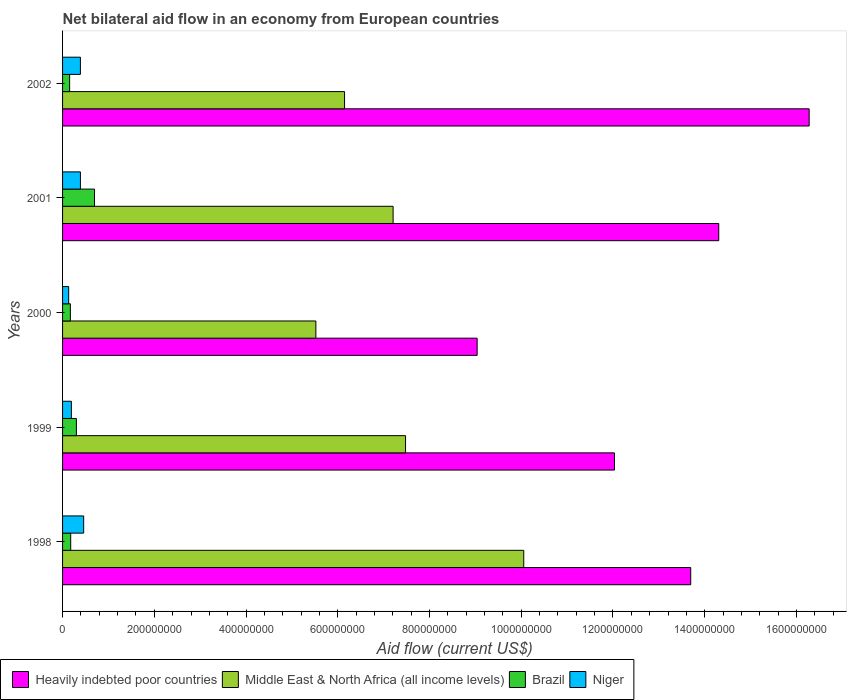How many groups of bars are there?
Your answer should be very brief. 5. Are the number of bars per tick equal to the number of legend labels?
Offer a terse response. Yes. How many bars are there on the 1st tick from the bottom?
Your response must be concise. 4. What is the label of the 2nd group of bars from the top?
Keep it short and to the point. 2001. In how many cases, is the number of bars for a given year not equal to the number of legend labels?
Offer a terse response. 0. What is the net bilateral aid flow in Heavily indebted poor countries in 2001?
Provide a succinct answer. 1.43e+09. Across all years, what is the maximum net bilateral aid flow in Middle East & North Africa (all income levels)?
Offer a very short reply. 1.01e+09. Across all years, what is the minimum net bilateral aid flow in Niger?
Your answer should be compact. 1.33e+07. In which year was the net bilateral aid flow in Brazil maximum?
Keep it short and to the point. 2001. In which year was the net bilateral aid flow in Heavily indebted poor countries minimum?
Keep it short and to the point. 2000. What is the total net bilateral aid flow in Brazil in the graph?
Give a very brief answer. 1.50e+08. What is the difference between the net bilateral aid flow in Brazil in 1999 and that in 2002?
Your answer should be very brief. 1.48e+07. What is the difference between the net bilateral aid flow in Niger in 2000 and the net bilateral aid flow in Heavily indebted poor countries in 1998?
Offer a terse response. -1.36e+09. What is the average net bilateral aid flow in Middle East & North Africa (all income levels) per year?
Keep it short and to the point. 7.28e+08. In the year 2000, what is the difference between the net bilateral aid flow in Brazil and net bilateral aid flow in Middle East & North Africa (all income levels)?
Offer a very short reply. -5.35e+08. What is the ratio of the net bilateral aid flow in Niger in 1998 to that in 2001?
Offer a very short reply. 1.18. What is the difference between the highest and the second highest net bilateral aid flow in Niger?
Keep it short and to the point. 7.09e+06. What is the difference between the highest and the lowest net bilateral aid flow in Heavily indebted poor countries?
Provide a short and direct response. 7.24e+08. In how many years, is the net bilateral aid flow in Heavily indebted poor countries greater than the average net bilateral aid flow in Heavily indebted poor countries taken over all years?
Provide a short and direct response. 3. Is the sum of the net bilateral aid flow in Middle East & North Africa (all income levels) in 2000 and 2001 greater than the maximum net bilateral aid flow in Niger across all years?
Your answer should be compact. Yes. Is it the case that in every year, the sum of the net bilateral aid flow in Heavily indebted poor countries and net bilateral aid flow in Niger is greater than the sum of net bilateral aid flow in Brazil and net bilateral aid flow in Middle East & North Africa (all income levels)?
Keep it short and to the point. No. What does the 4th bar from the top in 2001 represents?
Your answer should be compact. Heavily indebted poor countries. What does the 4th bar from the bottom in 1999 represents?
Ensure brevity in your answer.  Niger. How many years are there in the graph?
Ensure brevity in your answer.  5. Does the graph contain any zero values?
Your answer should be very brief. No. Where does the legend appear in the graph?
Offer a terse response. Bottom left. How many legend labels are there?
Ensure brevity in your answer.  4. How are the legend labels stacked?
Provide a succinct answer. Horizontal. What is the title of the graph?
Keep it short and to the point. Net bilateral aid flow in an economy from European countries. Does "Guinea-Bissau" appear as one of the legend labels in the graph?
Offer a terse response. No. What is the label or title of the X-axis?
Provide a short and direct response. Aid flow (current US$). What is the label or title of the Y-axis?
Your answer should be compact. Years. What is the Aid flow (current US$) of Heavily indebted poor countries in 1998?
Make the answer very short. 1.37e+09. What is the Aid flow (current US$) in Middle East & North Africa (all income levels) in 1998?
Offer a terse response. 1.01e+09. What is the Aid flow (current US$) of Brazil in 1998?
Make the answer very short. 1.77e+07. What is the Aid flow (current US$) in Niger in 1998?
Provide a succinct answer. 4.60e+07. What is the Aid flow (current US$) in Heavily indebted poor countries in 1999?
Your response must be concise. 1.20e+09. What is the Aid flow (current US$) in Middle East & North Africa (all income levels) in 1999?
Make the answer very short. 7.48e+08. What is the Aid flow (current US$) of Brazil in 1999?
Your answer should be very brief. 3.02e+07. What is the Aid flow (current US$) in Niger in 1999?
Provide a succinct answer. 1.92e+07. What is the Aid flow (current US$) in Heavily indebted poor countries in 2000?
Offer a terse response. 9.04e+08. What is the Aid flow (current US$) of Middle East & North Africa (all income levels) in 2000?
Offer a very short reply. 5.52e+08. What is the Aid flow (current US$) in Brazil in 2000?
Offer a very short reply. 1.70e+07. What is the Aid flow (current US$) of Niger in 2000?
Provide a short and direct response. 1.33e+07. What is the Aid flow (current US$) in Heavily indebted poor countries in 2001?
Ensure brevity in your answer.  1.43e+09. What is the Aid flow (current US$) of Middle East & North Africa (all income levels) in 2001?
Provide a succinct answer. 7.21e+08. What is the Aid flow (current US$) of Brazil in 2001?
Give a very brief answer. 6.97e+07. What is the Aid flow (current US$) of Niger in 2001?
Your answer should be compact. 3.89e+07. What is the Aid flow (current US$) of Heavily indebted poor countries in 2002?
Make the answer very short. 1.63e+09. What is the Aid flow (current US$) of Middle East & North Africa (all income levels) in 2002?
Offer a terse response. 6.15e+08. What is the Aid flow (current US$) of Brazil in 2002?
Make the answer very short. 1.54e+07. What is the Aid flow (current US$) of Niger in 2002?
Offer a very short reply. 3.89e+07. Across all years, what is the maximum Aid flow (current US$) of Heavily indebted poor countries?
Your answer should be compact. 1.63e+09. Across all years, what is the maximum Aid flow (current US$) of Middle East & North Africa (all income levels)?
Your response must be concise. 1.01e+09. Across all years, what is the maximum Aid flow (current US$) of Brazil?
Your answer should be very brief. 6.97e+07. Across all years, what is the maximum Aid flow (current US$) in Niger?
Offer a terse response. 4.60e+07. Across all years, what is the minimum Aid flow (current US$) in Heavily indebted poor countries?
Ensure brevity in your answer.  9.04e+08. Across all years, what is the minimum Aid flow (current US$) of Middle East & North Africa (all income levels)?
Make the answer very short. 5.52e+08. Across all years, what is the minimum Aid flow (current US$) in Brazil?
Your answer should be very brief. 1.54e+07. Across all years, what is the minimum Aid flow (current US$) in Niger?
Your answer should be very brief. 1.33e+07. What is the total Aid flow (current US$) of Heavily indebted poor countries in the graph?
Provide a succinct answer. 6.54e+09. What is the total Aid flow (current US$) in Middle East & North Africa (all income levels) in the graph?
Provide a succinct answer. 3.64e+09. What is the total Aid flow (current US$) in Brazil in the graph?
Keep it short and to the point. 1.50e+08. What is the total Aid flow (current US$) of Niger in the graph?
Your answer should be compact. 1.56e+08. What is the difference between the Aid flow (current US$) in Heavily indebted poor countries in 1998 and that in 1999?
Keep it short and to the point. 1.66e+08. What is the difference between the Aid flow (current US$) in Middle East & North Africa (all income levels) in 1998 and that in 1999?
Provide a succinct answer. 2.58e+08. What is the difference between the Aid flow (current US$) of Brazil in 1998 and that in 1999?
Offer a very short reply. -1.24e+07. What is the difference between the Aid flow (current US$) of Niger in 1998 and that in 1999?
Ensure brevity in your answer.  2.68e+07. What is the difference between the Aid flow (current US$) of Heavily indebted poor countries in 1998 and that in 2000?
Your answer should be very brief. 4.66e+08. What is the difference between the Aid flow (current US$) in Middle East & North Africa (all income levels) in 1998 and that in 2000?
Provide a succinct answer. 4.53e+08. What is the difference between the Aid flow (current US$) of Brazil in 1998 and that in 2000?
Offer a very short reply. 7.10e+05. What is the difference between the Aid flow (current US$) of Niger in 1998 and that in 2000?
Make the answer very short. 3.27e+07. What is the difference between the Aid flow (current US$) in Heavily indebted poor countries in 1998 and that in 2001?
Ensure brevity in your answer.  -6.11e+07. What is the difference between the Aid flow (current US$) in Middle East & North Africa (all income levels) in 1998 and that in 2001?
Offer a very short reply. 2.85e+08. What is the difference between the Aid flow (current US$) in Brazil in 1998 and that in 2001?
Provide a succinct answer. -5.19e+07. What is the difference between the Aid flow (current US$) in Niger in 1998 and that in 2001?
Keep it short and to the point. 7.09e+06. What is the difference between the Aid flow (current US$) in Heavily indebted poor countries in 1998 and that in 2002?
Your response must be concise. -2.58e+08. What is the difference between the Aid flow (current US$) in Middle East & North Africa (all income levels) in 1998 and that in 2002?
Make the answer very short. 3.91e+08. What is the difference between the Aid flow (current US$) in Brazil in 1998 and that in 2002?
Offer a very short reply. 2.33e+06. What is the difference between the Aid flow (current US$) of Niger in 1998 and that in 2002?
Your answer should be compact. 7.13e+06. What is the difference between the Aid flow (current US$) of Heavily indebted poor countries in 1999 and that in 2000?
Offer a very short reply. 2.99e+08. What is the difference between the Aid flow (current US$) of Middle East & North Africa (all income levels) in 1999 and that in 2000?
Ensure brevity in your answer.  1.96e+08. What is the difference between the Aid flow (current US$) of Brazil in 1999 and that in 2000?
Make the answer very short. 1.32e+07. What is the difference between the Aid flow (current US$) of Niger in 1999 and that in 2000?
Your answer should be very brief. 5.91e+06. What is the difference between the Aid flow (current US$) in Heavily indebted poor countries in 1999 and that in 2001?
Provide a succinct answer. -2.27e+08. What is the difference between the Aid flow (current US$) in Middle East & North Africa (all income levels) in 1999 and that in 2001?
Give a very brief answer. 2.71e+07. What is the difference between the Aid flow (current US$) of Brazil in 1999 and that in 2001?
Offer a very short reply. -3.95e+07. What is the difference between the Aid flow (current US$) in Niger in 1999 and that in 2001?
Offer a very short reply. -1.97e+07. What is the difference between the Aid flow (current US$) of Heavily indebted poor countries in 1999 and that in 2002?
Your answer should be compact. -4.24e+08. What is the difference between the Aid flow (current US$) in Middle East & North Africa (all income levels) in 1999 and that in 2002?
Offer a terse response. 1.33e+08. What is the difference between the Aid flow (current US$) of Brazil in 1999 and that in 2002?
Your answer should be compact. 1.48e+07. What is the difference between the Aid flow (current US$) of Niger in 1999 and that in 2002?
Offer a very short reply. -1.97e+07. What is the difference between the Aid flow (current US$) in Heavily indebted poor countries in 2000 and that in 2001?
Provide a short and direct response. -5.27e+08. What is the difference between the Aid flow (current US$) of Middle East & North Africa (all income levels) in 2000 and that in 2001?
Your answer should be compact. -1.68e+08. What is the difference between the Aid flow (current US$) of Brazil in 2000 and that in 2001?
Make the answer very short. -5.26e+07. What is the difference between the Aid flow (current US$) in Niger in 2000 and that in 2001?
Provide a succinct answer. -2.56e+07. What is the difference between the Aid flow (current US$) of Heavily indebted poor countries in 2000 and that in 2002?
Your answer should be very brief. -7.24e+08. What is the difference between the Aid flow (current US$) of Middle East & North Africa (all income levels) in 2000 and that in 2002?
Your answer should be very brief. -6.25e+07. What is the difference between the Aid flow (current US$) of Brazil in 2000 and that in 2002?
Your answer should be very brief. 1.62e+06. What is the difference between the Aid flow (current US$) of Niger in 2000 and that in 2002?
Ensure brevity in your answer.  -2.56e+07. What is the difference between the Aid flow (current US$) in Heavily indebted poor countries in 2001 and that in 2002?
Your answer should be very brief. -1.97e+08. What is the difference between the Aid flow (current US$) in Middle East & North Africa (all income levels) in 2001 and that in 2002?
Provide a succinct answer. 1.06e+08. What is the difference between the Aid flow (current US$) in Brazil in 2001 and that in 2002?
Provide a short and direct response. 5.43e+07. What is the difference between the Aid flow (current US$) of Heavily indebted poor countries in 1998 and the Aid flow (current US$) of Middle East & North Africa (all income levels) in 1999?
Offer a terse response. 6.22e+08. What is the difference between the Aid flow (current US$) in Heavily indebted poor countries in 1998 and the Aid flow (current US$) in Brazil in 1999?
Ensure brevity in your answer.  1.34e+09. What is the difference between the Aid flow (current US$) of Heavily indebted poor countries in 1998 and the Aid flow (current US$) of Niger in 1999?
Offer a very short reply. 1.35e+09. What is the difference between the Aid flow (current US$) of Middle East & North Africa (all income levels) in 1998 and the Aid flow (current US$) of Brazil in 1999?
Ensure brevity in your answer.  9.75e+08. What is the difference between the Aid flow (current US$) of Middle East & North Africa (all income levels) in 1998 and the Aid flow (current US$) of Niger in 1999?
Provide a succinct answer. 9.86e+08. What is the difference between the Aid flow (current US$) of Brazil in 1998 and the Aid flow (current US$) of Niger in 1999?
Your response must be concise. -1.49e+06. What is the difference between the Aid flow (current US$) of Heavily indebted poor countries in 1998 and the Aid flow (current US$) of Middle East & North Africa (all income levels) in 2000?
Offer a terse response. 8.17e+08. What is the difference between the Aid flow (current US$) in Heavily indebted poor countries in 1998 and the Aid flow (current US$) in Brazil in 2000?
Your answer should be very brief. 1.35e+09. What is the difference between the Aid flow (current US$) in Heavily indebted poor countries in 1998 and the Aid flow (current US$) in Niger in 2000?
Make the answer very short. 1.36e+09. What is the difference between the Aid flow (current US$) of Middle East & North Africa (all income levels) in 1998 and the Aid flow (current US$) of Brazil in 2000?
Your response must be concise. 9.88e+08. What is the difference between the Aid flow (current US$) of Middle East & North Africa (all income levels) in 1998 and the Aid flow (current US$) of Niger in 2000?
Make the answer very short. 9.92e+08. What is the difference between the Aid flow (current US$) of Brazil in 1998 and the Aid flow (current US$) of Niger in 2000?
Offer a terse response. 4.42e+06. What is the difference between the Aid flow (current US$) in Heavily indebted poor countries in 1998 and the Aid flow (current US$) in Middle East & North Africa (all income levels) in 2001?
Your response must be concise. 6.49e+08. What is the difference between the Aid flow (current US$) in Heavily indebted poor countries in 1998 and the Aid flow (current US$) in Brazil in 2001?
Make the answer very short. 1.30e+09. What is the difference between the Aid flow (current US$) in Heavily indebted poor countries in 1998 and the Aid flow (current US$) in Niger in 2001?
Your answer should be very brief. 1.33e+09. What is the difference between the Aid flow (current US$) of Middle East & North Africa (all income levels) in 1998 and the Aid flow (current US$) of Brazil in 2001?
Your answer should be compact. 9.36e+08. What is the difference between the Aid flow (current US$) in Middle East & North Africa (all income levels) in 1998 and the Aid flow (current US$) in Niger in 2001?
Your answer should be compact. 9.67e+08. What is the difference between the Aid flow (current US$) in Brazil in 1998 and the Aid flow (current US$) in Niger in 2001?
Your answer should be compact. -2.12e+07. What is the difference between the Aid flow (current US$) in Heavily indebted poor countries in 1998 and the Aid flow (current US$) in Middle East & North Africa (all income levels) in 2002?
Your response must be concise. 7.55e+08. What is the difference between the Aid flow (current US$) in Heavily indebted poor countries in 1998 and the Aid flow (current US$) in Brazil in 2002?
Your response must be concise. 1.35e+09. What is the difference between the Aid flow (current US$) of Heavily indebted poor countries in 1998 and the Aid flow (current US$) of Niger in 2002?
Your response must be concise. 1.33e+09. What is the difference between the Aid flow (current US$) of Middle East & North Africa (all income levels) in 1998 and the Aid flow (current US$) of Brazil in 2002?
Give a very brief answer. 9.90e+08. What is the difference between the Aid flow (current US$) in Middle East & North Africa (all income levels) in 1998 and the Aid flow (current US$) in Niger in 2002?
Your response must be concise. 9.67e+08. What is the difference between the Aid flow (current US$) of Brazil in 1998 and the Aid flow (current US$) of Niger in 2002?
Give a very brief answer. -2.12e+07. What is the difference between the Aid flow (current US$) in Heavily indebted poor countries in 1999 and the Aid flow (current US$) in Middle East & North Africa (all income levels) in 2000?
Make the answer very short. 6.51e+08. What is the difference between the Aid flow (current US$) of Heavily indebted poor countries in 1999 and the Aid flow (current US$) of Brazil in 2000?
Your response must be concise. 1.19e+09. What is the difference between the Aid flow (current US$) of Heavily indebted poor countries in 1999 and the Aid flow (current US$) of Niger in 2000?
Your answer should be compact. 1.19e+09. What is the difference between the Aid flow (current US$) in Middle East & North Africa (all income levels) in 1999 and the Aid flow (current US$) in Brazil in 2000?
Provide a short and direct response. 7.31e+08. What is the difference between the Aid flow (current US$) in Middle East & North Africa (all income levels) in 1999 and the Aid flow (current US$) in Niger in 2000?
Provide a succinct answer. 7.34e+08. What is the difference between the Aid flow (current US$) in Brazil in 1999 and the Aid flow (current US$) in Niger in 2000?
Your response must be concise. 1.69e+07. What is the difference between the Aid flow (current US$) in Heavily indebted poor countries in 1999 and the Aid flow (current US$) in Middle East & North Africa (all income levels) in 2001?
Keep it short and to the point. 4.83e+08. What is the difference between the Aid flow (current US$) of Heavily indebted poor countries in 1999 and the Aid flow (current US$) of Brazil in 2001?
Your response must be concise. 1.13e+09. What is the difference between the Aid flow (current US$) of Heavily indebted poor countries in 1999 and the Aid flow (current US$) of Niger in 2001?
Provide a short and direct response. 1.16e+09. What is the difference between the Aid flow (current US$) in Middle East & North Africa (all income levels) in 1999 and the Aid flow (current US$) in Brazil in 2001?
Offer a very short reply. 6.78e+08. What is the difference between the Aid flow (current US$) of Middle East & North Africa (all income levels) in 1999 and the Aid flow (current US$) of Niger in 2001?
Give a very brief answer. 7.09e+08. What is the difference between the Aid flow (current US$) of Brazil in 1999 and the Aid flow (current US$) of Niger in 2001?
Your answer should be very brief. -8.74e+06. What is the difference between the Aid flow (current US$) in Heavily indebted poor countries in 1999 and the Aid flow (current US$) in Middle East & North Africa (all income levels) in 2002?
Provide a succinct answer. 5.88e+08. What is the difference between the Aid flow (current US$) in Heavily indebted poor countries in 1999 and the Aid flow (current US$) in Brazil in 2002?
Offer a very short reply. 1.19e+09. What is the difference between the Aid flow (current US$) of Heavily indebted poor countries in 1999 and the Aid flow (current US$) of Niger in 2002?
Your answer should be very brief. 1.16e+09. What is the difference between the Aid flow (current US$) in Middle East & North Africa (all income levels) in 1999 and the Aid flow (current US$) in Brazil in 2002?
Keep it short and to the point. 7.32e+08. What is the difference between the Aid flow (current US$) in Middle East & North Africa (all income levels) in 1999 and the Aid flow (current US$) in Niger in 2002?
Give a very brief answer. 7.09e+08. What is the difference between the Aid flow (current US$) of Brazil in 1999 and the Aid flow (current US$) of Niger in 2002?
Offer a very short reply. -8.70e+06. What is the difference between the Aid flow (current US$) in Heavily indebted poor countries in 2000 and the Aid flow (current US$) in Middle East & North Africa (all income levels) in 2001?
Provide a short and direct response. 1.83e+08. What is the difference between the Aid flow (current US$) in Heavily indebted poor countries in 2000 and the Aid flow (current US$) in Brazil in 2001?
Give a very brief answer. 8.34e+08. What is the difference between the Aid flow (current US$) in Heavily indebted poor countries in 2000 and the Aid flow (current US$) in Niger in 2001?
Your answer should be compact. 8.65e+08. What is the difference between the Aid flow (current US$) in Middle East & North Africa (all income levels) in 2000 and the Aid flow (current US$) in Brazil in 2001?
Give a very brief answer. 4.83e+08. What is the difference between the Aid flow (current US$) of Middle East & North Africa (all income levels) in 2000 and the Aid flow (current US$) of Niger in 2001?
Keep it short and to the point. 5.13e+08. What is the difference between the Aid flow (current US$) of Brazil in 2000 and the Aid flow (current US$) of Niger in 2001?
Offer a very short reply. -2.19e+07. What is the difference between the Aid flow (current US$) of Heavily indebted poor countries in 2000 and the Aid flow (current US$) of Middle East & North Africa (all income levels) in 2002?
Your response must be concise. 2.89e+08. What is the difference between the Aid flow (current US$) in Heavily indebted poor countries in 2000 and the Aid flow (current US$) in Brazil in 2002?
Offer a very short reply. 8.89e+08. What is the difference between the Aid flow (current US$) of Heavily indebted poor countries in 2000 and the Aid flow (current US$) of Niger in 2002?
Keep it short and to the point. 8.65e+08. What is the difference between the Aid flow (current US$) in Middle East & North Africa (all income levels) in 2000 and the Aid flow (current US$) in Brazil in 2002?
Your answer should be compact. 5.37e+08. What is the difference between the Aid flow (current US$) in Middle East & North Africa (all income levels) in 2000 and the Aid flow (current US$) in Niger in 2002?
Provide a short and direct response. 5.13e+08. What is the difference between the Aid flow (current US$) in Brazil in 2000 and the Aid flow (current US$) in Niger in 2002?
Your answer should be very brief. -2.19e+07. What is the difference between the Aid flow (current US$) of Heavily indebted poor countries in 2001 and the Aid flow (current US$) of Middle East & North Africa (all income levels) in 2002?
Provide a succinct answer. 8.16e+08. What is the difference between the Aid flow (current US$) in Heavily indebted poor countries in 2001 and the Aid flow (current US$) in Brazil in 2002?
Offer a terse response. 1.42e+09. What is the difference between the Aid flow (current US$) of Heavily indebted poor countries in 2001 and the Aid flow (current US$) of Niger in 2002?
Ensure brevity in your answer.  1.39e+09. What is the difference between the Aid flow (current US$) of Middle East & North Africa (all income levels) in 2001 and the Aid flow (current US$) of Brazil in 2002?
Make the answer very short. 7.05e+08. What is the difference between the Aid flow (current US$) of Middle East & North Africa (all income levels) in 2001 and the Aid flow (current US$) of Niger in 2002?
Make the answer very short. 6.82e+08. What is the difference between the Aid flow (current US$) of Brazil in 2001 and the Aid flow (current US$) of Niger in 2002?
Your response must be concise. 3.08e+07. What is the average Aid flow (current US$) in Heavily indebted poor countries per year?
Ensure brevity in your answer.  1.31e+09. What is the average Aid flow (current US$) in Middle East & North Africa (all income levels) per year?
Your answer should be compact. 7.28e+08. What is the average Aid flow (current US$) in Brazil per year?
Keep it short and to the point. 3.00e+07. What is the average Aid flow (current US$) in Niger per year?
Offer a very short reply. 3.13e+07. In the year 1998, what is the difference between the Aid flow (current US$) of Heavily indebted poor countries and Aid flow (current US$) of Middle East & North Africa (all income levels)?
Offer a very short reply. 3.64e+08. In the year 1998, what is the difference between the Aid flow (current US$) of Heavily indebted poor countries and Aid flow (current US$) of Brazil?
Your answer should be very brief. 1.35e+09. In the year 1998, what is the difference between the Aid flow (current US$) in Heavily indebted poor countries and Aid flow (current US$) in Niger?
Keep it short and to the point. 1.32e+09. In the year 1998, what is the difference between the Aid flow (current US$) in Middle East & North Africa (all income levels) and Aid flow (current US$) in Brazil?
Offer a very short reply. 9.88e+08. In the year 1998, what is the difference between the Aid flow (current US$) of Middle East & North Africa (all income levels) and Aid flow (current US$) of Niger?
Offer a very short reply. 9.59e+08. In the year 1998, what is the difference between the Aid flow (current US$) in Brazil and Aid flow (current US$) in Niger?
Your response must be concise. -2.83e+07. In the year 1999, what is the difference between the Aid flow (current US$) of Heavily indebted poor countries and Aid flow (current US$) of Middle East & North Africa (all income levels)?
Your response must be concise. 4.55e+08. In the year 1999, what is the difference between the Aid flow (current US$) in Heavily indebted poor countries and Aid flow (current US$) in Brazil?
Give a very brief answer. 1.17e+09. In the year 1999, what is the difference between the Aid flow (current US$) of Heavily indebted poor countries and Aid flow (current US$) of Niger?
Make the answer very short. 1.18e+09. In the year 1999, what is the difference between the Aid flow (current US$) in Middle East & North Africa (all income levels) and Aid flow (current US$) in Brazil?
Your answer should be compact. 7.18e+08. In the year 1999, what is the difference between the Aid flow (current US$) of Middle East & North Africa (all income levels) and Aid flow (current US$) of Niger?
Offer a terse response. 7.29e+08. In the year 1999, what is the difference between the Aid flow (current US$) in Brazil and Aid flow (current US$) in Niger?
Ensure brevity in your answer.  1.10e+07. In the year 2000, what is the difference between the Aid flow (current US$) of Heavily indebted poor countries and Aid flow (current US$) of Middle East & North Africa (all income levels)?
Your response must be concise. 3.52e+08. In the year 2000, what is the difference between the Aid flow (current US$) of Heavily indebted poor countries and Aid flow (current US$) of Brazil?
Keep it short and to the point. 8.87e+08. In the year 2000, what is the difference between the Aid flow (current US$) in Heavily indebted poor countries and Aid flow (current US$) in Niger?
Keep it short and to the point. 8.91e+08. In the year 2000, what is the difference between the Aid flow (current US$) of Middle East & North Africa (all income levels) and Aid flow (current US$) of Brazil?
Ensure brevity in your answer.  5.35e+08. In the year 2000, what is the difference between the Aid flow (current US$) in Middle East & North Africa (all income levels) and Aid flow (current US$) in Niger?
Ensure brevity in your answer.  5.39e+08. In the year 2000, what is the difference between the Aid flow (current US$) of Brazil and Aid flow (current US$) of Niger?
Offer a terse response. 3.71e+06. In the year 2001, what is the difference between the Aid flow (current US$) in Heavily indebted poor countries and Aid flow (current US$) in Middle East & North Africa (all income levels)?
Give a very brief answer. 7.10e+08. In the year 2001, what is the difference between the Aid flow (current US$) in Heavily indebted poor countries and Aid flow (current US$) in Brazil?
Provide a short and direct response. 1.36e+09. In the year 2001, what is the difference between the Aid flow (current US$) in Heavily indebted poor countries and Aid flow (current US$) in Niger?
Provide a succinct answer. 1.39e+09. In the year 2001, what is the difference between the Aid flow (current US$) of Middle East & North Africa (all income levels) and Aid flow (current US$) of Brazil?
Keep it short and to the point. 6.51e+08. In the year 2001, what is the difference between the Aid flow (current US$) of Middle East & North Africa (all income levels) and Aid flow (current US$) of Niger?
Provide a succinct answer. 6.82e+08. In the year 2001, what is the difference between the Aid flow (current US$) of Brazil and Aid flow (current US$) of Niger?
Your answer should be very brief. 3.07e+07. In the year 2002, what is the difference between the Aid flow (current US$) in Heavily indebted poor countries and Aid flow (current US$) in Middle East & North Africa (all income levels)?
Your response must be concise. 1.01e+09. In the year 2002, what is the difference between the Aid flow (current US$) of Heavily indebted poor countries and Aid flow (current US$) of Brazil?
Give a very brief answer. 1.61e+09. In the year 2002, what is the difference between the Aid flow (current US$) of Heavily indebted poor countries and Aid flow (current US$) of Niger?
Your answer should be very brief. 1.59e+09. In the year 2002, what is the difference between the Aid flow (current US$) in Middle East & North Africa (all income levels) and Aid flow (current US$) in Brazil?
Provide a succinct answer. 5.99e+08. In the year 2002, what is the difference between the Aid flow (current US$) in Middle East & North Africa (all income levels) and Aid flow (current US$) in Niger?
Provide a succinct answer. 5.76e+08. In the year 2002, what is the difference between the Aid flow (current US$) in Brazil and Aid flow (current US$) in Niger?
Give a very brief answer. -2.35e+07. What is the ratio of the Aid flow (current US$) in Heavily indebted poor countries in 1998 to that in 1999?
Your response must be concise. 1.14. What is the ratio of the Aid flow (current US$) in Middle East & North Africa (all income levels) in 1998 to that in 1999?
Make the answer very short. 1.34. What is the ratio of the Aid flow (current US$) of Brazil in 1998 to that in 1999?
Make the answer very short. 0.59. What is the ratio of the Aid flow (current US$) in Niger in 1998 to that in 1999?
Provide a succinct answer. 2.39. What is the ratio of the Aid flow (current US$) of Heavily indebted poor countries in 1998 to that in 2000?
Your answer should be compact. 1.52. What is the ratio of the Aid flow (current US$) in Middle East & North Africa (all income levels) in 1998 to that in 2000?
Ensure brevity in your answer.  1.82. What is the ratio of the Aid flow (current US$) in Brazil in 1998 to that in 2000?
Give a very brief answer. 1.04. What is the ratio of the Aid flow (current US$) of Niger in 1998 to that in 2000?
Your response must be concise. 3.46. What is the ratio of the Aid flow (current US$) in Heavily indebted poor countries in 1998 to that in 2001?
Give a very brief answer. 0.96. What is the ratio of the Aid flow (current US$) of Middle East & North Africa (all income levels) in 1998 to that in 2001?
Provide a short and direct response. 1.4. What is the ratio of the Aid flow (current US$) in Brazil in 1998 to that in 2001?
Keep it short and to the point. 0.25. What is the ratio of the Aid flow (current US$) in Niger in 1998 to that in 2001?
Keep it short and to the point. 1.18. What is the ratio of the Aid flow (current US$) in Heavily indebted poor countries in 1998 to that in 2002?
Keep it short and to the point. 0.84. What is the ratio of the Aid flow (current US$) of Middle East & North Africa (all income levels) in 1998 to that in 2002?
Make the answer very short. 1.64. What is the ratio of the Aid flow (current US$) in Brazil in 1998 to that in 2002?
Provide a short and direct response. 1.15. What is the ratio of the Aid flow (current US$) of Niger in 1998 to that in 2002?
Offer a very short reply. 1.18. What is the ratio of the Aid flow (current US$) in Heavily indebted poor countries in 1999 to that in 2000?
Give a very brief answer. 1.33. What is the ratio of the Aid flow (current US$) in Middle East & North Africa (all income levels) in 1999 to that in 2000?
Your answer should be compact. 1.35. What is the ratio of the Aid flow (current US$) of Brazil in 1999 to that in 2000?
Give a very brief answer. 1.77. What is the ratio of the Aid flow (current US$) of Niger in 1999 to that in 2000?
Offer a very short reply. 1.44. What is the ratio of the Aid flow (current US$) of Heavily indebted poor countries in 1999 to that in 2001?
Keep it short and to the point. 0.84. What is the ratio of the Aid flow (current US$) of Middle East & North Africa (all income levels) in 1999 to that in 2001?
Make the answer very short. 1.04. What is the ratio of the Aid flow (current US$) in Brazil in 1999 to that in 2001?
Your response must be concise. 0.43. What is the ratio of the Aid flow (current US$) of Niger in 1999 to that in 2001?
Keep it short and to the point. 0.49. What is the ratio of the Aid flow (current US$) in Heavily indebted poor countries in 1999 to that in 2002?
Your response must be concise. 0.74. What is the ratio of the Aid flow (current US$) in Middle East & North Africa (all income levels) in 1999 to that in 2002?
Offer a very short reply. 1.22. What is the ratio of the Aid flow (current US$) in Brazil in 1999 to that in 2002?
Ensure brevity in your answer.  1.96. What is the ratio of the Aid flow (current US$) in Niger in 1999 to that in 2002?
Offer a very short reply. 0.49. What is the ratio of the Aid flow (current US$) of Heavily indebted poor countries in 2000 to that in 2001?
Give a very brief answer. 0.63. What is the ratio of the Aid flow (current US$) in Middle East & North Africa (all income levels) in 2000 to that in 2001?
Your response must be concise. 0.77. What is the ratio of the Aid flow (current US$) in Brazil in 2000 to that in 2001?
Offer a terse response. 0.24. What is the ratio of the Aid flow (current US$) in Niger in 2000 to that in 2001?
Your answer should be very brief. 0.34. What is the ratio of the Aid flow (current US$) of Heavily indebted poor countries in 2000 to that in 2002?
Give a very brief answer. 0.56. What is the ratio of the Aid flow (current US$) of Middle East & North Africa (all income levels) in 2000 to that in 2002?
Keep it short and to the point. 0.9. What is the ratio of the Aid flow (current US$) in Brazil in 2000 to that in 2002?
Keep it short and to the point. 1.11. What is the ratio of the Aid flow (current US$) in Niger in 2000 to that in 2002?
Your response must be concise. 0.34. What is the ratio of the Aid flow (current US$) of Heavily indebted poor countries in 2001 to that in 2002?
Keep it short and to the point. 0.88. What is the ratio of the Aid flow (current US$) in Middle East & North Africa (all income levels) in 2001 to that in 2002?
Give a very brief answer. 1.17. What is the ratio of the Aid flow (current US$) of Brazil in 2001 to that in 2002?
Keep it short and to the point. 4.52. What is the difference between the highest and the second highest Aid flow (current US$) in Heavily indebted poor countries?
Ensure brevity in your answer.  1.97e+08. What is the difference between the highest and the second highest Aid flow (current US$) in Middle East & North Africa (all income levels)?
Provide a short and direct response. 2.58e+08. What is the difference between the highest and the second highest Aid flow (current US$) in Brazil?
Provide a short and direct response. 3.95e+07. What is the difference between the highest and the second highest Aid flow (current US$) of Niger?
Keep it short and to the point. 7.09e+06. What is the difference between the highest and the lowest Aid flow (current US$) of Heavily indebted poor countries?
Give a very brief answer. 7.24e+08. What is the difference between the highest and the lowest Aid flow (current US$) in Middle East & North Africa (all income levels)?
Your response must be concise. 4.53e+08. What is the difference between the highest and the lowest Aid flow (current US$) of Brazil?
Your response must be concise. 5.43e+07. What is the difference between the highest and the lowest Aid flow (current US$) of Niger?
Offer a terse response. 3.27e+07. 